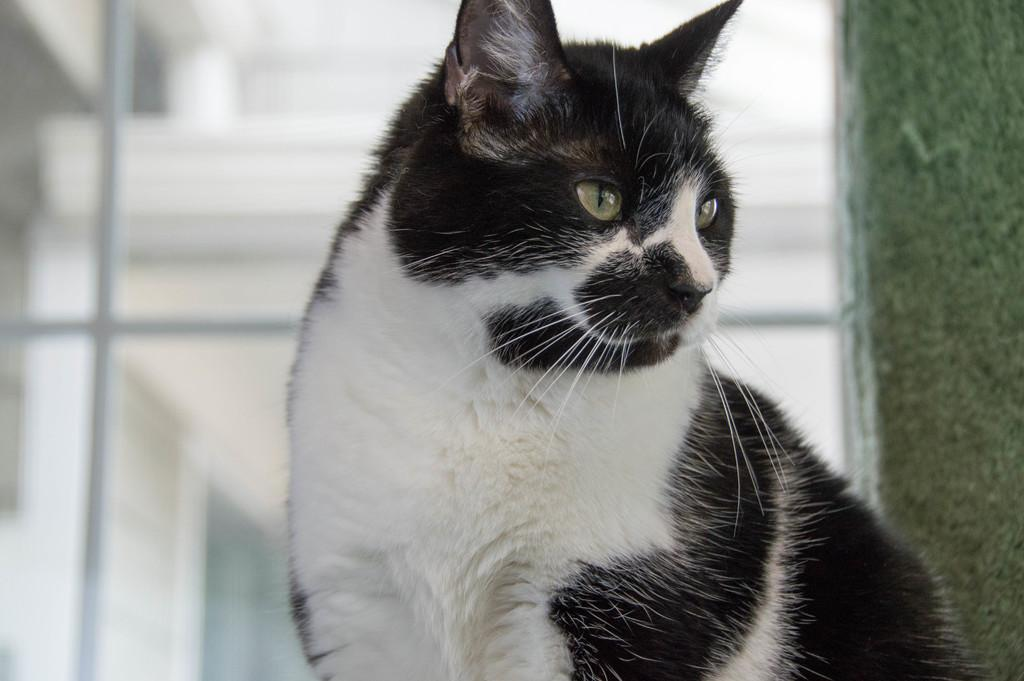What type of animal is in the image? There is a black and white cat in the image. Can you describe the background of the image? The background of the image is blurred. What type of knowledge can be gained from the cat's expression in the image? There is no indication of the cat's expression in the image, and therefore no knowledge can be gained from it. 